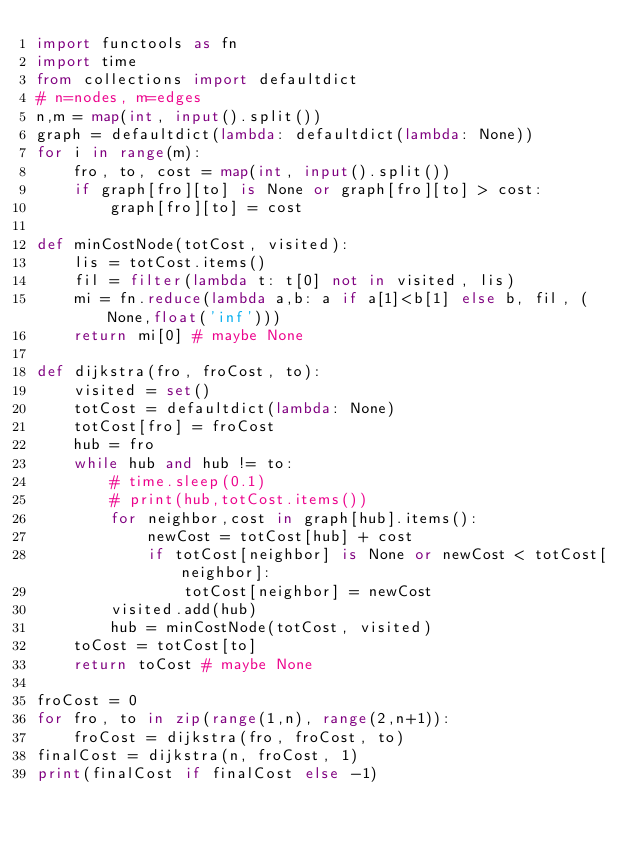Convert code to text. <code><loc_0><loc_0><loc_500><loc_500><_Python_>import functools as fn
import time
from collections import defaultdict
# n=nodes, m=edges
n,m = map(int, input().split())
graph = defaultdict(lambda: defaultdict(lambda: None))
for i in range(m):
    fro, to, cost = map(int, input().split())
    if graph[fro][to] is None or graph[fro][to] > cost:
        graph[fro][to] = cost

def minCostNode(totCost, visited):
    lis = totCost.items()
    fil = filter(lambda t: t[0] not in visited, lis)
    mi = fn.reduce(lambda a,b: a if a[1]<b[1] else b, fil, (None,float('inf')))
    return mi[0] # maybe None

def dijkstra(fro, froCost, to):
    visited = set()
    totCost = defaultdict(lambda: None)
    totCost[fro] = froCost
    hub = fro
    while hub and hub != to:
        # time.sleep(0.1)
        # print(hub,totCost.items())
        for neighbor,cost in graph[hub].items():
            newCost = totCost[hub] + cost
            if totCost[neighbor] is None or newCost < totCost[neighbor]:
                totCost[neighbor] = newCost
        visited.add(hub)
        hub = minCostNode(totCost, visited)
    toCost = totCost[to]
    return toCost # maybe None

froCost = 0
for fro, to in zip(range(1,n), range(2,n+1)):
    froCost = dijkstra(fro, froCost, to)
finalCost = dijkstra(n, froCost, 1)
print(finalCost if finalCost else -1)

</code> 